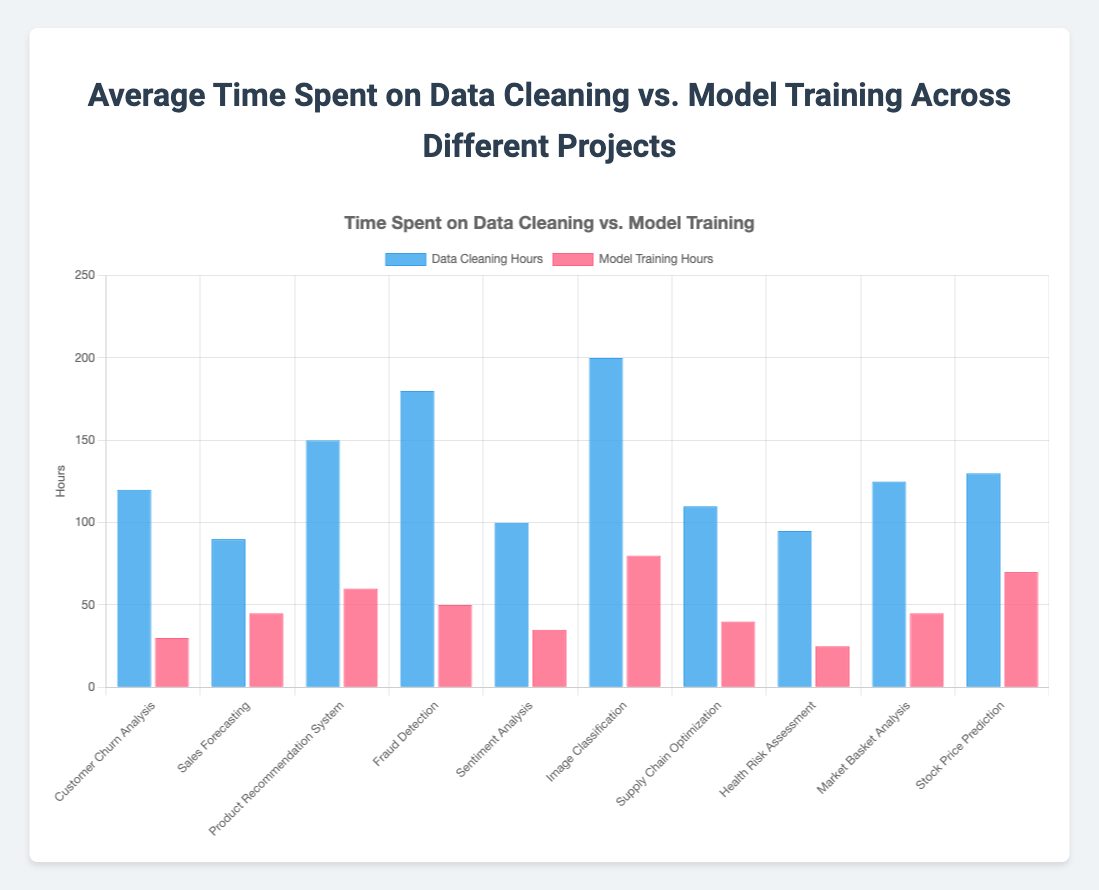Which project has the highest total time spent (data cleaning + model training)? To find the project with the highest total time spent, we calculate the sum of data cleaning hours and model training hours for each project, then compare the totals. Image Classification has the highest total time (200 + 80 = 280 hours).
Answer: Image Classification Which project spent more time on model training than data cleaning? By comparing the data cleaning hours and model training hours for each project, none of the projects have model training hours greater than the data cleaning hours.
Answer: None What's the ratio of data cleaning to model training for Fraud Detection? The data cleaning hours for Fraud Detection are 180 and the model training hours are 50. The ratio is 180/50 = 3.6.
Answer: 3.6 Compare the time spent on model training for Product Recommendation System and Market Basket Analysis. Which spent more? Product Recommendation System spent 60 hours on model training, while Market Basket Analysis spent 45 hours. Product Recommendation System spent more time.
Answer: Product Recommendation System Which project has the least time spent on data cleaning? By inspecting the heights of the blue bars representing data cleaning hours, Health Risk Assessment has the smallest bar, indicating the least amount of time spent on data cleaning (95 hours).
Answer: Health Risk Assessment What’s the combined time spent on model training for Customer Churn Analysis and Sentiment Analysis? Adding the model training hours for both projects: Customer Churn Analysis (30) and Sentiment Analysis (35). The combined time is 30 + 35 = 65 hours.
Answer: 65 Find the project with the highest discrepancy between data cleaning and model training hours. The project with the highest difference is Image Classification, with the discrepancy being 200 - 80 = 120 hours.
Answer: Image Classification In which project does the sum of data cleaning and model training hours equal 170? Calculating for each project, Sales Forecasting has 90 (data cleaning) + 45 (model training) + Market Basket Analysis has the same. Both sums equal 170 hours.
Answer: Sales Forecasting, Market Basket Analysis 